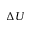Convert formula to latex. <formula><loc_0><loc_0><loc_500><loc_500>\Delta U</formula> 